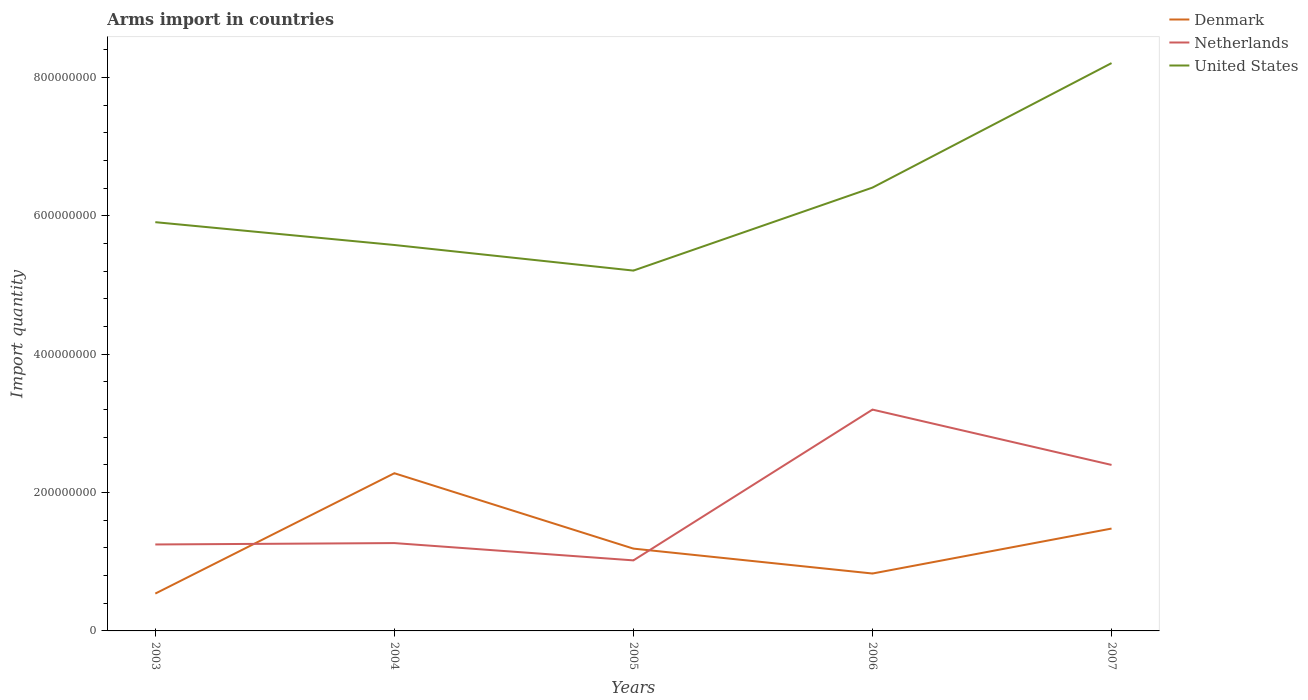Does the line corresponding to Netherlands intersect with the line corresponding to United States?
Provide a short and direct response. No. Is the number of lines equal to the number of legend labels?
Offer a very short reply. Yes. Across all years, what is the maximum total arms import in Denmark?
Your answer should be compact. 5.40e+07. What is the total total arms import in United States in the graph?
Provide a short and direct response. -2.30e+08. What is the difference between the highest and the second highest total arms import in Denmark?
Provide a short and direct response. 1.74e+08. How many lines are there?
Your answer should be very brief. 3. What is the difference between two consecutive major ticks on the Y-axis?
Provide a succinct answer. 2.00e+08. Are the values on the major ticks of Y-axis written in scientific E-notation?
Make the answer very short. No. Does the graph contain any zero values?
Give a very brief answer. No. Does the graph contain grids?
Offer a terse response. No. Where does the legend appear in the graph?
Keep it short and to the point. Top right. How many legend labels are there?
Ensure brevity in your answer.  3. How are the legend labels stacked?
Give a very brief answer. Vertical. What is the title of the graph?
Your answer should be very brief. Arms import in countries. What is the label or title of the X-axis?
Keep it short and to the point. Years. What is the label or title of the Y-axis?
Provide a succinct answer. Import quantity. What is the Import quantity of Denmark in 2003?
Provide a succinct answer. 5.40e+07. What is the Import quantity in Netherlands in 2003?
Offer a very short reply. 1.25e+08. What is the Import quantity of United States in 2003?
Keep it short and to the point. 5.91e+08. What is the Import quantity of Denmark in 2004?
Your response must be concise. 2.28e+08. What is the Import quantity in Netherlands in 2004?
Your answer should be very brief. 1.27e+08. What is the Import quantity of United States in 2004?
Provide a succinct answer. 5.58e+08. What is the Import quantity of Denmark in 2005?
Provide a succinct answer. 1.19e+08. What is the Import quantity in Netherlands in 2005?
Make the answer very short. 1.02e+08. What is the Import quantity in United States in 2005?
Your answer should be compact. 5.21e+08. What is the Import quantity in Denmark in 2006?
Provide a succinct answer. 8.30e+07. What is the Import quantity in Netherlands in 2006?
Provide a succinct answer. 3.20e+08. What is the Import quantity of United States in 2006?
Offer a very short reply. 6.41e+08. What is the Import quantity of Denmark in 2007?
Offer a terse response. 1.48e+08. What is the Import quantity of Netherlands in 2007?
Offer a terse response. 2.40e+08. What is the Import quantity in United States in 2007?
Keep it short and to the point. 8.21e+08. Across all years, what is the maximum Import quantity of Denmark?
Ensure brevity in your answer.  2.28e+08. Across all years, what is the maximum Import quantity of Netherlands?
Provide a short and direct response. 3.20e+08. Across all years, what is the maximum Import quantity in United States?
Make the answer very short. 8.21e+08. Across all years, what is the minimum Import quantity of Denmark?
Your answer should be compact. 5.40e+07. Across all years, what is the minimum Import quantity of Netherlands?
Your answer should be very brief. 1.02e+08. Across all years, what is the minimum Import quantity in United States?
Your answer should be very brief. 5.21e+08. What is the total Import quantity in Denmark in the graph?
Provide a succinct answer. 6.32e+08. What is the total Import quantity of Netherlands in the graph?
Your answer should be compact. 9.14e+08. What is the total Import quantity in United States in the graph?
Keep it short and to the point. 3.13e+09. What is the difference between the Import quantity of Denmark in 2003 and that in 2004?
Keep it short and to the point. -1.74e+08. What is the difference between the Import quantity in United States in 2003 and that in 2004?
Offer a terse response. 3.30e+07. What is the difference between the Import quantity in Denmark in 2003 and that in 2005?
Make the answer very short. -6.50e+07. What is the difference between the Import quantity of Netherlands in 2003 and that in 2005?
Ensure brevity in your answer.  2.30e+07. What is the difference between the Import quantity in United States in 2003 and that in 2005?
Provide a succinct answer. 7.00e+07. What is the difference between the Import quantity of Denmark in 2003 and that in 2006?
Give a very brief answer. -2.90e+07. What is the difference between the Import quantity in Netherlands in 2003 and that in 2006?
Your answer should be very brief. -1.95e+08. What is the difference between the Import quantity in United States in 2003 and that in 2006?
Your response must be concise. -5.00e+07. What is the difference between the Import quantity in Denmark in 2003 and that in 2007?
Ensure brevity in your answer.  -9.40e+07. What is the difference between the Import quantity in Netherlands in 2003 and that in 2007?
Your response must be concise. -1.15e+08. What is the difference between the Import quantity in United States in 2003 and that in 2007?
Make the answer very short. -2.30e+08. What is the difference between the Import quantity of Denmark in 2004 and that in 2005?
Provide a short and direct response. 1.09e+08. What is the difference between the Import quantity in Netherlands in 2004 and that in 2005?
Offer a very short reply. 2.50e+07. What is the difference between the Import quantity in United States in 2004 and that in 2005?
Provide a short and direct response. 3.70e+07. What is the difference between the Import quantity of Denmark in 2004 and that in 2006?
Your answer should be very brief. 1.45e+08. What is the difference between the Import quantity in Netherlands in 2004 and that in 2006?
Ensure brevity in your answer.  -1.93e+08. What is the difference between the Import quantity in United States in 2004 and that in 2006?
Provide a short and direct response. -8.30e+07. What is the difference between the Import quantity in Denmark in 2004 and that in 2007?
Offer a very short reply. 8.00e+07. What is the difference between the Import quantity in Netherlands in 2004 and that in 2007?
Ensure brevity in your answer.  -1.13e+08. What is the difference between the Import quantity of United States in 2004 and that in 2007?
Your answer should be very brief. -2.63e+08. What is the difference between the Import quantity of Denmark in 2005 and that in 2006?
Provide a succinct answer. 3.60e+07. What is the difference between the Import quantity in Netherlands in 2005 and that in 2006?
Your answer should be compact. -2.18e+08. What is the difference between the Import quantity in United States in 2005 and that in 2006?
Make the answer very short. -1.20e+08. What is the difference between the Import quantity of Denmark in 2005 and that in 2007?
Ensure brevity in your answer.  -2.90e+07. What is the difference between the Import quantity in Netherlands in 2005 and that in 2007?
Your answer should be compact. -1.38e+08. What is the difference between the Import quantity in United States in 2005 and that in 2007?
Provide a succinct answer. -3.00e+08. What is the difference between the Import quantity of Denmark in 2006 and that in 2007?
Offer a very short reply. -6.50e+07. What is the difference between the Import quantity of Netherlands in 2006 and that in 2007?
Offer a very short reply. 8.00e+07. What is the difference between the Import quantity in United States in 2006 and that in 2007?
Your answer should be compact. -1.80e+08. What is the difference between the Import quantity in Denmark in 2003 and the Import quantity in Netherlands in 2004?
Keep it short and to the point. -7.30e+07. What is the difference between the Import quantity of Denmark in 2003 and the Import quantity of United States in 2004?
Your answer should be very brief. -5.04e+08. What is the difference between the Import quantity in Netherlands in 2003 and the Import quantity in United States in 2004?
Provide a succinct answer. -4.33e+08. What is the difference between the Import quantity of Denmark in 2003 and the Import quantity of Netherlands in 2005?
Your response must be concise. -4.80e+07. What is the difference between the Import quantity in Denmark in 2003 and the Import quantity in United States in 2005?
Provide a short and direct response. -4.67e+08. What is the difference between the Import quantity in Netherlands in 2003 and the Import quantity in United States in 2005?
Ensure brevity in your answer.  -3.96e+08. What is the difference between the Import quantity of Denmark in 2003 and the Import quantity of Netherlands in 2006?
Your answer should be very brief. -2.66e+08. What is the difference between the Import quantity in Denmark in 2003 and the Import quantity in United States in 2006?
Ensure brevity in your answer.  -5.87e+08. What is the difference between the Import quantity of Netherlands in 2003 and the Import quantity of United States in 2006?
Provide a succinct answer. -5.16e+08. What is the difference between the Import quantity of Denmark in 2003 and the Import quantity of Netherlands in 2007?
Your answer should be very brief. -1.86e+08. What is the difference between the Import quantity in Denmark in 2003 and the Import quantity in United States in 2007?
Offer a very short reply. -7.67e+08. What is the difference between the Import quantity in Netherlands in 2003 and the Import quantity in United States in 2007?
Your answer should be very brief. -6.96e+08. What is the difference between the Import quantity in Denmark in 2004 and the Import quantity in Netherlands in 2005?
Your response must be concise. 1.26e+08. What is the difference between the Import quantity in Denmark in 2004 and the Import quantity in United States in 2005?
Ensure brevity in your answer.  -2.93e+08. What is the difference between the Import quantity of Netherlands in 2004 and the Import quantity of United States in 2005?
Keep it short and to the point. -3.94e+08. What is the difference between the Import quantity in Denmark in 2004 and the Import quantity in Netherlands in 2006?
Your response must be concise. -9.20e+07. What is the difference between the Import quantity of Denmark in 2004 and the Import quantity of United States in 2006?
Provide a succinct answer. -4.13e+08. What is the difference between the Import quantity of Netherlands in 2004 and the Import quantity of United States in 2006?
Ensure brevity in your answer.  -5.14e+08. What is the difference between the Import quantity of Denmark in 2004 and the Import quantity of Netherlands in 2007?
Provide a succinct answer. -1.20e+07. What is the difference between the Import quantity of Denmark in 2004 and the Import quantity of United States in 2007?
Offer a terse response. -5.93e+08. What is the difference between the Import quantity of Netherlands in 2004 and the Import quantity of United States in 2007?
Your answer should be compact. -6.94e+08. What is the difference between the Import quantity of Denmark in 2005 and the Import quantity of Netherlands in 2006?
Your response must be concise. -2.01e+08. What is the difference between the Import quantity in Denmark in 2005 and the Import quantity in United States in 2006?
Keep it short and to the point. -5.22e+08. What is the difference between the Import quantity in Netherlands in 2005 and the Import quantity in United States in 2006?
Your answer should be very brief. -5.39e+08. What is the difference between the Import quantity in Denmark in 2005 and the Import quantity in Netherlands in 2007?
Your answer should be compact. -1.21e+08. What is the difference between the Import quantity of Denmark in 2005 and the Import quantity of United States in 2007?
Your response must be concise. -7.02e+08. What is the difference between the Import quantity in Netherlands in 2005 and the Import quantity in United States in 2007?
Make the answer very short. -7.19e+08. What is the difference between the Import quantity in Denmark in 2006 and the Import quantity in Netherlands in 2007?
Provide a short and direct response. -1.57e+08. What is the difference between the Import quantity in Denmark in 2006 and the Import quantity in United States in 2007?
Keep it short and to the point. -7.38e+08. What is the difference between the Import quantity in Netherlands in 2006 and the Import quantity in United States in 2007?
Provide a short and direct response. -5.01e+08. What is the average Import quantity in Denmark per year?
Provide a short and direct response. 1.26e+08. What is the average Import quantity of Netherlands per year?
Ensure brevity in your answer.  1.83e+08. What is the average Import quantity of United States per year?
Make the answer very short. 6.26e+08. In the year 2003, what is the difference between the Import quantity in Denmark and Import quantity in Netherlands?
Provide a short and direct response. -7.10e+07. In the year 2003, what is the difference between the Import quantity of Denmark and Import quantity of United States?
Ensure brevity in your answer.  -5.37e+08. In the year 2003, what is the difference between the Import quantity of Netherlands and Import quantity of United States?
Give a very brief answer. -4.66e+08. In the year 2004, what is the difference between the Import quantity in Denmark and Import quantity in Netherlands?
Your answer should be very brief. 1.01e+08. In the year 2004, what is the difference between the Import quantity in Denmark and Import quantity in United States?
Your answer should be very brief. -3.30e+08. In the year 2004, what is the difference between the Import quantity in Netherlands and Import quantity in United States?
Make the answer very short. -4.31e+08. In the year 2005, what is the difference between the Import quantity in Denmark and Import quantity in Netherlands?
Make the answer very short. 1.70e+07. In the year 2005, what is the difference between the Import quantity of Denmark and Import quantity of United States?
Your answer should be very brief. -4.02e+08. In the year 2005, what is the difference between the Import quantity of Netherlands and Import quantity of United States?
Your answer should be compact. -4.19e+08. In the year 2006, what is the difference between the Import quantity in Denmark and Import quantity in Netherlands?
Ensure brevity in your answer.  -2.37e+08. In the year 2006, what is the difference between the Import quantity of Denmark and Import quantity of United States?
Your answer should be very brief. -5.58e+08. In the year 2006, what is the difference between the Import quantity in Netherlands and Import quantity in United States?
Ensure brevity in your answer.  -3.21e+08. In the year 2007, what is the difference between the Import quantity in Denmark and Import quantity in Netherlands?
Provide a short and direct response. -9.20e+07. In the year 2007, what is the difference between the Import quantity of Denmark and Import quantity of United States?
Offer a terse response. -6.73e+08. In the year 2007, what is the difference between the Import quantity of Netherlands and Import quantity of United States?
Your response must be concise. -5.81e+08. What is the ratio of the Import quantity in Denmark in 2003 to that in 2004?
Offer a very short reply. 0.24. What is the ratio of the Import quantity of Netherlands in 2003 to that in 2004?
Provide a short and direct response. 0.98. What is the ratio of the Import quantity of United States in 2003 to that in 2004?
Offer a terse response. 1.06. What is the ratio of the Import quantity in Denmark in 2003 to that in 2005?
Provide a short and direct response. 0.45. What is the ratio of the Import quantity of Netherlands in 2003 to that in 2005?
Provide a succinct answer. 1.23. What is the ratio of the Import quantity in United States in 2003 to that in 2005?
Your response must be concise. 1.13. What is the ratio of the Import quantity in Denmark in 2003 to that in 2006?
Keep it short and to the point. 0.65. What is the ratio of the Import quantity in Netherlands in 2003 to that in 2006?
Your answer should be very brief. 0.39. What is the ratio of the Import quantity in United States in 2003 to that in 2006?
Your response must be concise. 0.92. What is the ratio of the Import quantity of Denmark in 2003 to that in 2007?
Offer a very short reply. 0.36. What is the ratio of the Import quantity in Netherlands in 2003 to that in 2007?
Your answer should be compact. 0.52. What is the ratio of the Import quantity in United States in 2003 to that in 2007?
Offer a terse response. 0.72. What is the ratio of the Import quantity in Denmark in 2004 to that in 2005?
Offer a terse response. 1.92. What is the ratio of the Import quantity in Netherlands in 2004 to that in 2005?
Offer a terse response. 1.25. What is the ratio of the Import quantity of United States in 2004 to that in 2005?
Provide a short and direct response. 1.07. What is the ratio of the Import quantity of Denmark in 2004 to that in 2006?
Make the answer very short. 2.75. What is the ratio of the Import quantity of Netherlands in 2004 to that in 2006?
Provide a succinct answer. 0.4. What is the ratio of the Import quantity of United States in 2004 to that in 2006?
Your answer should be compact. 0.87. What is the ratio of the Import quantity in Denmark in 2004 to that in 2007?
Your response must be concise. 1.54. What is the ratio of the Import quantity of Netherlands in 2004 to that in 2007?
Your answer should be compact. 0.53. What is the ratio of the Import quantity of United States in 2004 to that in 2007?
Make the answer very short. 0.68. What is the ratio of the Import quantity of Denmark in 2005 to that in 2006?
Offer a terse response. 1.43. What is the ratio of the Import quantity of Netherlands in 2005 to that in 2006?
Offer a very short reply. 0.32. What is the ratio of the Import quantity of United States in 2005 to that in 2006?
Give a very brief answer. 0.81. What is the ratio of the Import quantity in Denmark in 2005 to that in 2007?
Your response must be concise. 0.8. What is the ratio of the Import quantity in Netherlands in 2005 to that in 2007?
Give a very brief answer. 0.42. What is the ratio of the Import quantity of United States in 2005 to that in 2007?
Make the answer very short. 0.63. What is the ratio of the Import quantity of Denmark in 2006 to that in 2007?
Provide a succinct answer. 0.56. What is the ratio of the Import quantity in United States in 2006 to that in 2007?
Make the answer very short. 0.78. What is the difference between the highest and the second highest Import quantity in Denmark?
Ensure brevity in your answer.  8.00e+07. What is the difference between the highest and the second highest Import quantity of Netherlands?
Your answer should be very brief. 8.00e+07. What is the difference between the highest and the second highest Import quantity in United States?
Provide a short and direct response. 1.80e+08. What is the difference between the highest and the lowest Import quantity in Denmark?
Make the answer very short. 1.74e+08. What is the difference between the highest and the lowest Import quantity in Netherlands?
Your response must be concise. 2.18e+08. What is the difference between the highest and the lowest Import quantity of United States?
Give a very brief answer. 3.00e+08. 